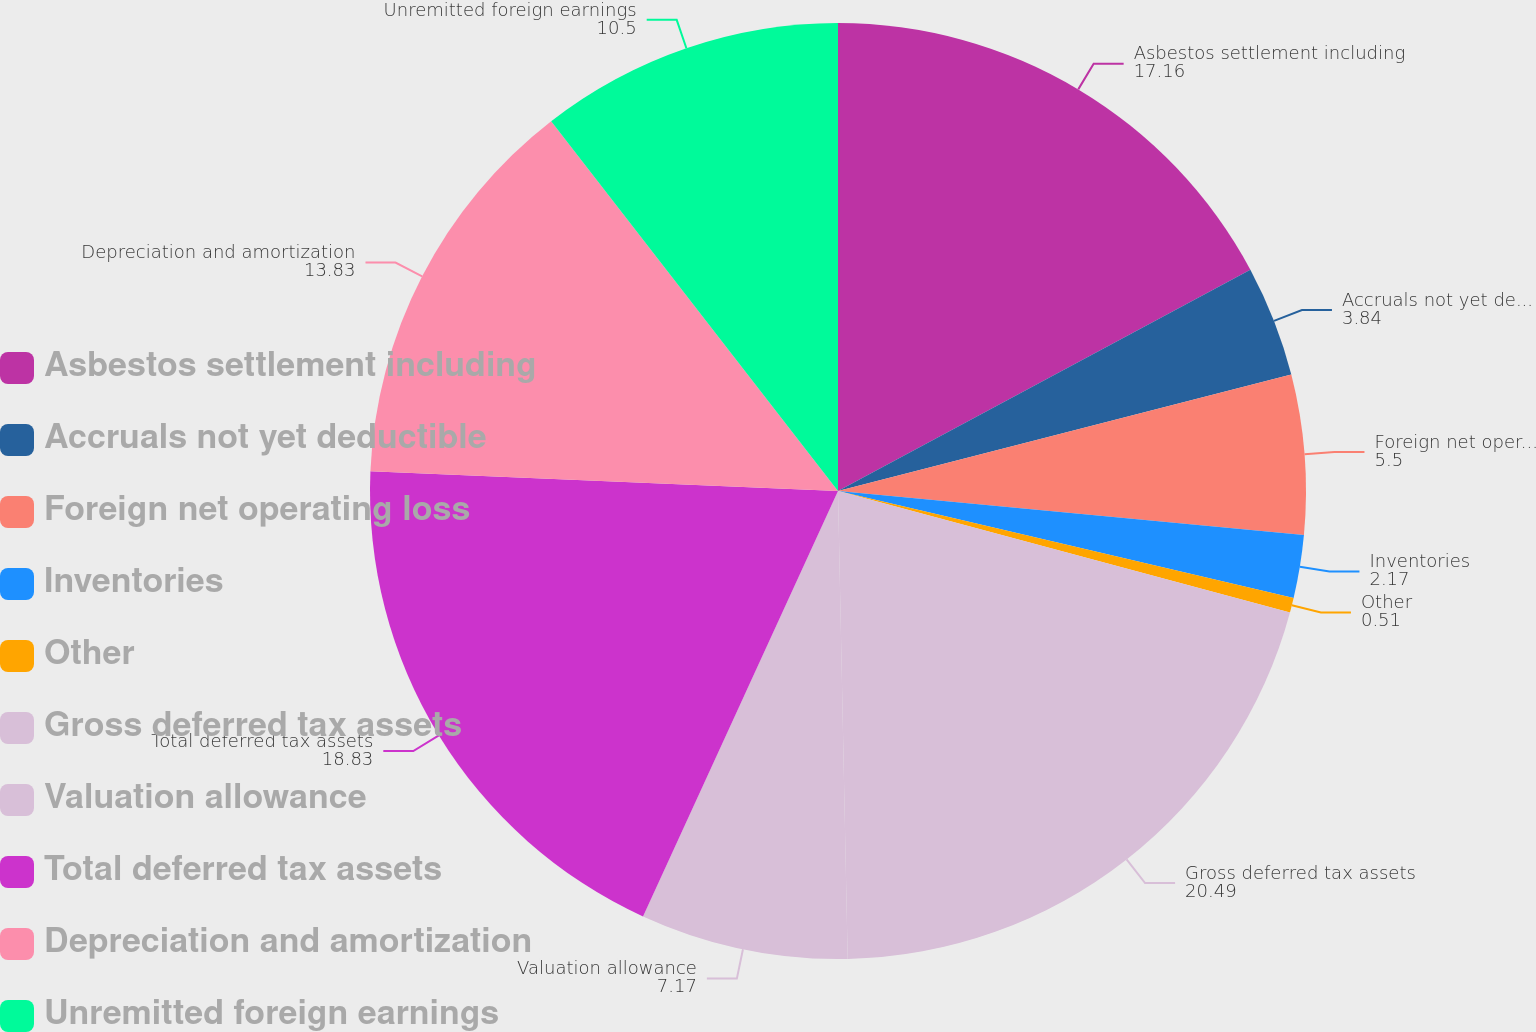Convert chart. <chart><loc_0><loc_0><loc_500><loc_500><pie_chart><fcel>Asbestos settlement including<fcel>Accruals not yet deductible<fcel>Foreign net operating loss<fcel>Inventories<fcel>Other<fcel>Gross deferred tax assets<fcel>Valuation allowance<fcel>Total deferred tax assets<fcel>Depreciation and amortization<fcel>Unremitted foreign earnings<nl><fcel>17.16%<fcel>3.84%<fcel>5.5%<fcel>2.17%<fcel>0.51%<fcel>20.49%<fcel>7.17%<fcel>18.83%<fcel>13.83%<fcel>10.5%<nl></chart> 